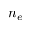Convert formula to latex. <formula><loc_0><loc_0><loc_500><loc_500>n _ { e }</formula> 